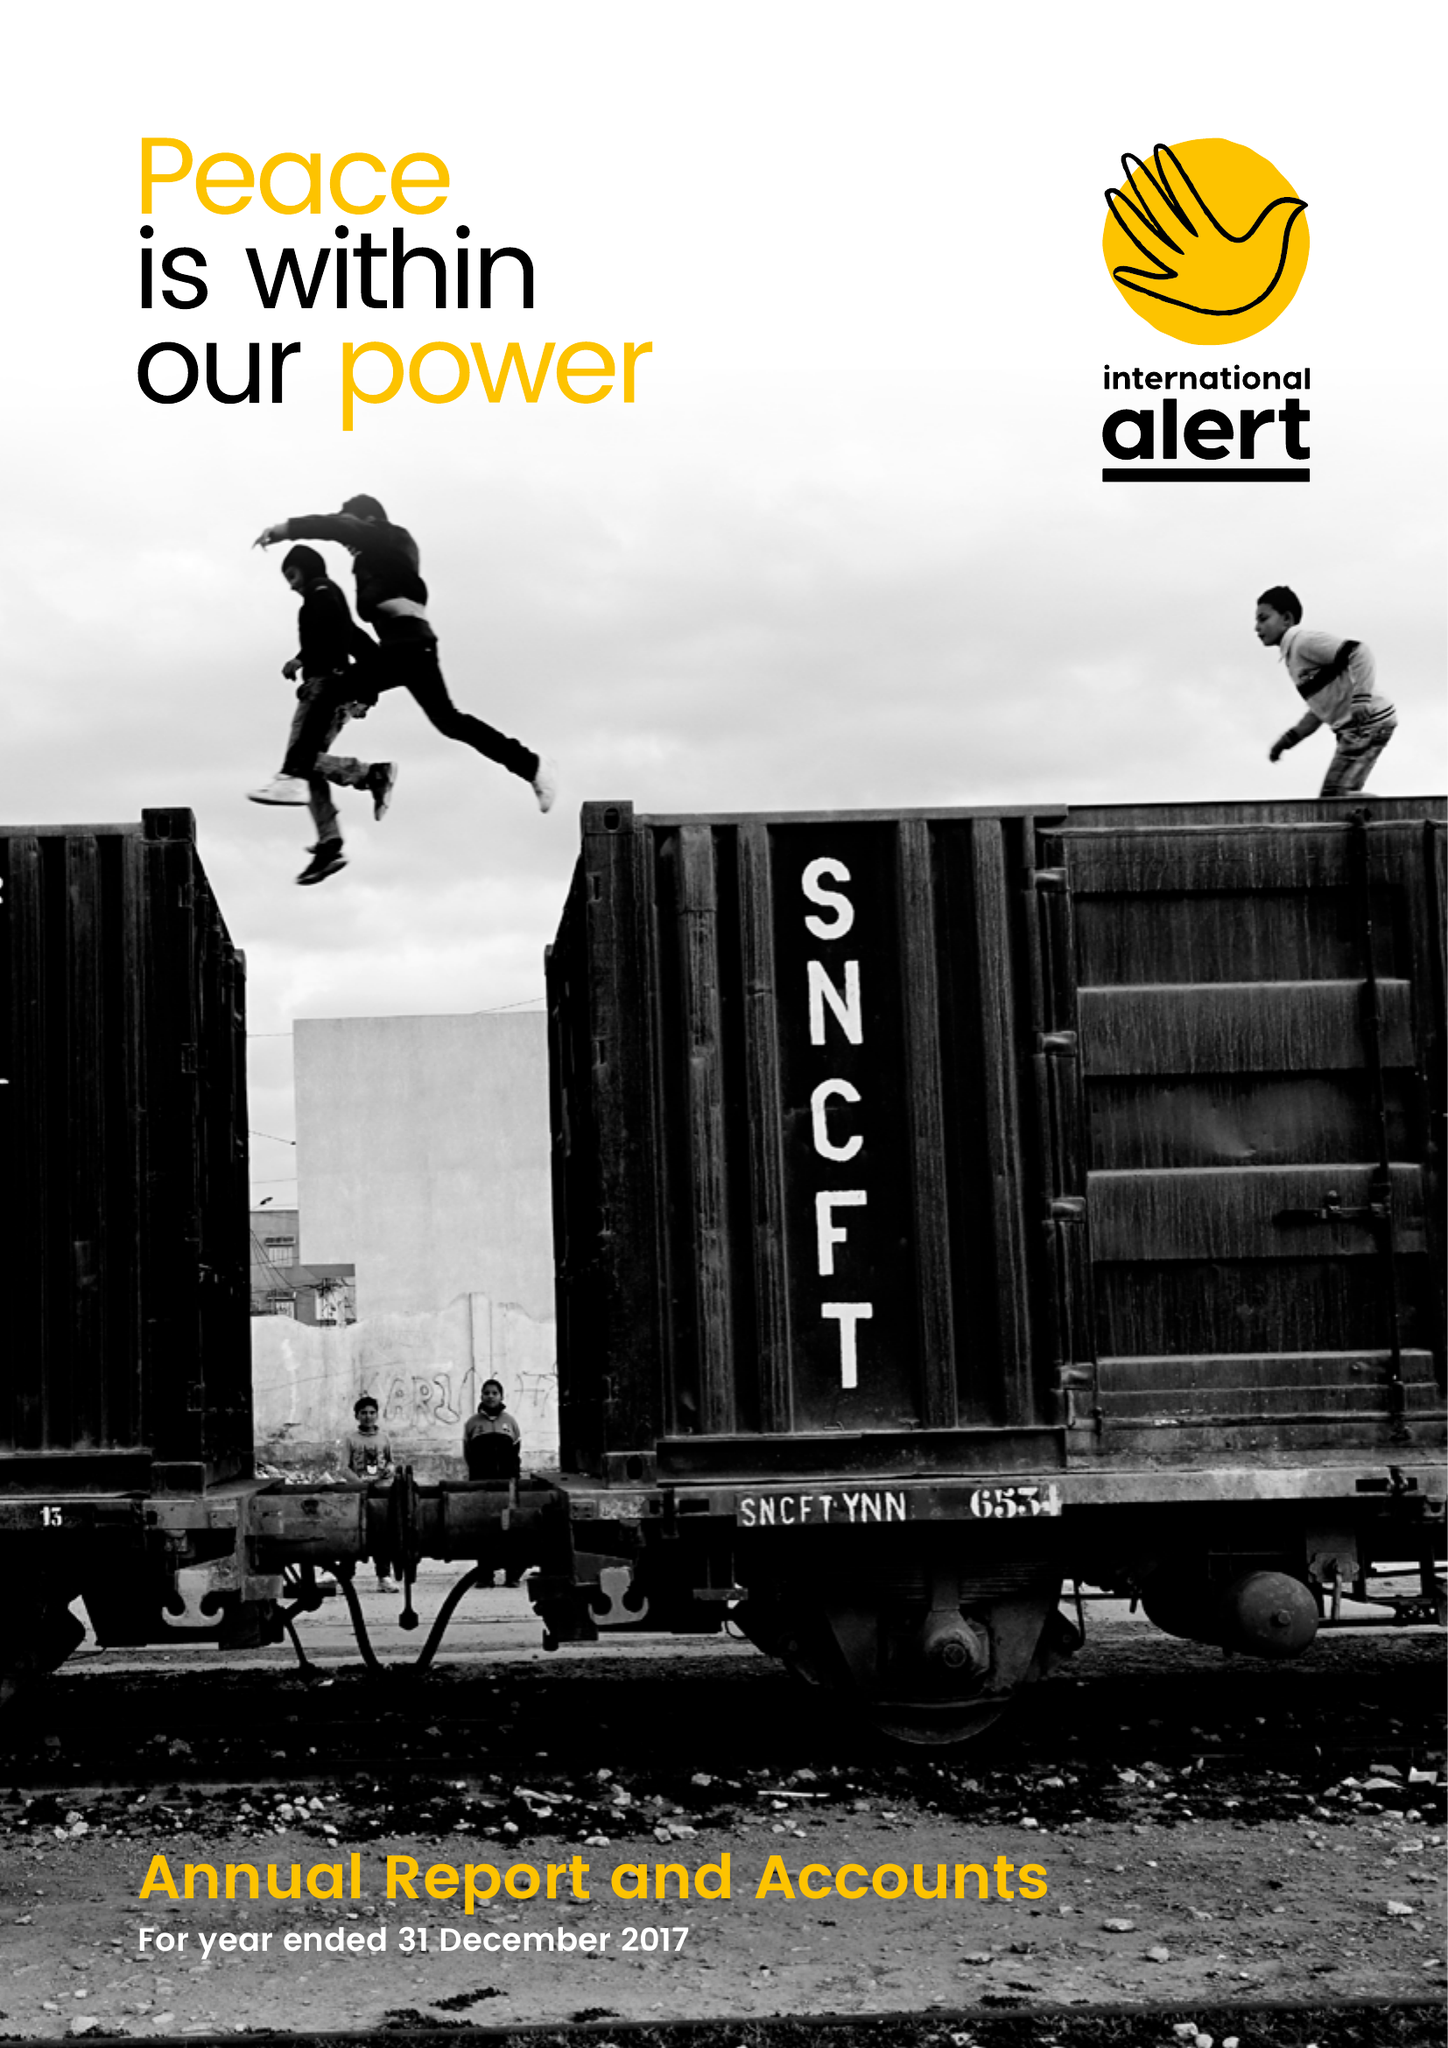What is the value for the charity_number?
Answer the question using a single word or phrase. 327553 